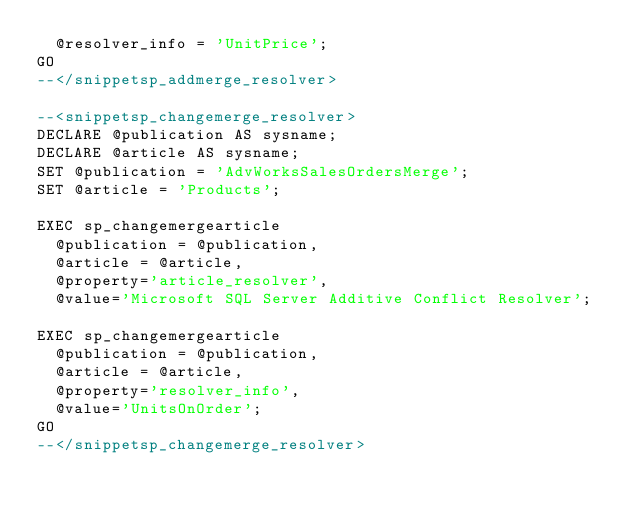<code> <loc_0><loc_0><loc_500><loc_500><_SQL_>	@resolver_info = 'UnitPrice';
GO
--</snippetsp_addmerge_resolver>

--<snippetsp_changemerge_resolver>
DECLARE @publication AS sysname;
DECLARE @article AS sysname;
SET @publication = 'AdvWorksSalesOrdersMerge';
SET @article = 'Products';

EXEC sp_changemergearticle 
	@publication = @publication, 
	@article = @article, 
	@property='article_resolver', 
	@value='Microsoft SQL Server Additive Conflict Resolver';

EXEC sp_changemergearticle 
	@publication = @publication, 
	@article = @article, 
	@property='resolver_info', 
	@value='UnitsOnOrder';
GO
--</snippetsp_changemerge_resolver>
</code> 